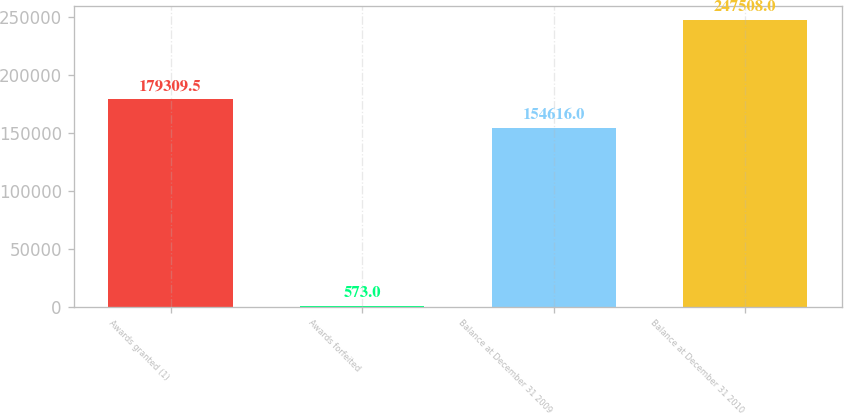Convert chart to OTSL. <chart><loc_0><loc_0><loc_500><loc_500><bar_chart><fcel>Awards granted (1)<fcel>Awards forfeited<fcel>Balance at December 31 2009<fcel>Balance at December 31 2010<nl><fcel>179310<fcel>573<fcel>154616<fcel>247508<nl></chart> 